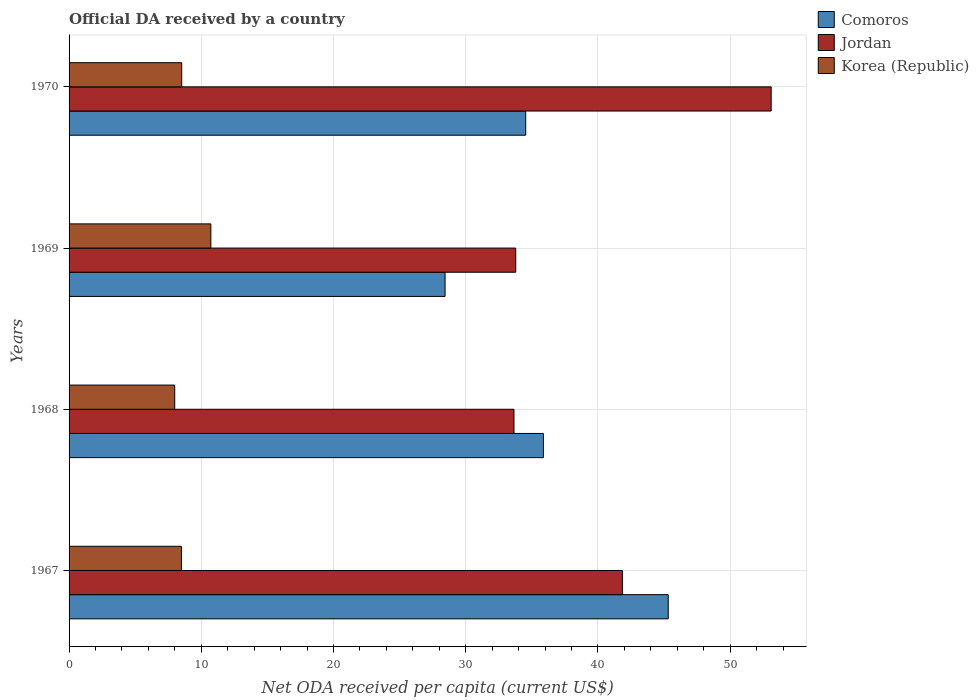How many groups of bars are there?
Keep it short and to the point. 4. How many bars are there on the 2nd tick from the top?
Make the answer very short. 3. How many bars are there on the 1st tick from the bottom?
Ensure brevity in your answer.  3. What is the label of the 4th group of bars from the top?
Your response must be concise. 1967. In how many cases, is the number of bars for a given year not equal to the number of legend labels?
Give a very brief answer. 0. What is the ODA received in in Jordan in 1968?
Give a very brief answer. 33.65. Across all years, what is the maximum ODA received in in Jordan?
Offer a terse response. 53.1. Across all years, what is the minimum ODA received in in Comoros?
Your answer should be very brief. 28.44. In which year was the ODA received in in Korea (Republic) maximum?
Your answer should be compact. 1969. In which year was the ODA received in in Korea (Republic) minimum?
Offer a terse response. 1968. What is the total ODA received in in Korea (Republic) in the graph?
Ensure brevity in your answer.  35.73. What is the difference between the ODA received in in Korea (Republic) in 1968 and that in 1970?
Your answer should be very brief. -0.53. What is the difference between the ODA received in in Korea (Republic) in 1969 and the ODA received in in Jordan in 1968?
Keep it short and to the point. -22.93. What is the average ODA received in in Jordan per year?
Your answer should be very brief. 40.6. In the year 1969, what is the difference between the ODA received in in Korea (Republic) and ODA received in in Jordan?
Make the answer very short. -23.06. What is the ratio of the ODA received in in Korea (Republic) in 1968 to that in 1969?
Ensure brevity in your answer.  0.75. What is the difference between the highest and the second highest ODA received in in Comoros?
Provide a short and direct response. 9.44. What is the difference between the highest and the lowest ODA received in in Jordan?
Your response must be concise. 19.45. Is the sum of the ODA received in in Korea (Republic) in 1967 and 1969 greater than the maximum ODA received in in Jordan across all years?
Offer a very short reply. No. What does the 1st bar from the bottom in 1967 represents?
Provide a short and direct response. Comoros. Are the values on the major ticks of X-axis written in scientific E-notation?
Keep it short and to the point. No. Does the graph contain grids?
Make the answer very short. Yes. How many legend labels are there?
Give a very brief answer. 3. How are the legend labels stacked?
Make the answer very short. Vertical. What is the title of the graph?
Provide a succinct answer. Official DA received by a country. What is the label or title of the X-axis?
Your response must be concise. Net ODA received per capita (current US$). What is the Net ODA received per capita (current US$) in Comoros in 1967?
Provide a succinct answer. 45.32. What is the Net ODA received per capita (current US$) in Jordan in 1967?
Your answer should be compact. 41.85. What is the Net ODA received per capita (current US$) in Korea (Republic) in 1967?
Offer a very short reply. 8.5. What is the Net ODA received per capita (current US$) in Comoros in 1968?
Keep it short and to the point. 35.88. What is the Net ODA received per capita (current US$) of Jordan in 1968?
Your answer should be compact. 33.65. What is the Net ODA received per capita (current US$) of Korea (Republic) in 1968?
Your response must be concise. 7.99. What is the Net ODA received per capita (current US$) of Comoros in 1969?
Keep it short and to the point. 28.44. What is the Net ODA received per capita (current US$) in Jordan in 1969?
Provide a succinct answer. 33.78. What is the Net ODA received per capita (current US$) in Korea (Republic) in 1969?
Your response must be concise. 10.72. What is the Net ODA received per capita (current US$) of Comoros in 1970?
Provide a short and direct response. 34.54. What is the Net ODA received per capita (current US$) in Jordan in 1970?
Give a very brief answer. 53.1. What is the Net ODA received per capita (current US$) in Korea (Republic) in 1970?
Give a very brief answer. 8.52. Across all years, what is the maximum Net ODA received per capita (current US$) in Comoros?
Offer a terse response. 45.32. Across all years, what is the maximum Net ODA received per capita (current US$) in Jordan?
Provide a short and direct response. 53.1. Across all years, what is the maximum Net ODA received per capita (current US$) of Korea (Republic)?
Your answer should be very brief. 10.72. Across all years, what is the minimum Net ODA received per capita (current US$) of Comoros?
Your response must be concise. 28.44. Across all years, what is the minimum Net ODA received per capita (current US$) of Jordan?
Your answer should be compact. 33.65. Across all years, what is the minimum Net ODA received per capita (current US$) in Korea (Republic)?
Give a very brief answer. 7.99. What is the total Net ODA received per capita (current US$) of Comoros in the graph?
Offer a terse response. 144.18. What is the total Net ODA received per capita (current US$) of Jordan in the graph?
Your response must be concise. 162.39. What is the total Net ODA received per capita (current US$) of Korea (Republic) in the graph?
Make the answer very short. 35.73. What is the difference between the Net ODA received per capita (current US$) in Comoros in 1967 and that in 1968?
Provide a short and direct response. 9.44. What is the difference between the Net ODA received per capita (current US$) in Jordan in 1967 and that in 1968?
Make the answer very short. 8.2. What is the difference between the Net ODA received per capita (current US$) in Korea (Republic) in 1967 and that in 1968?
Your response must be concise. 0.51. What is the difference between the Net ODA received per capita (current US$) of Comoros in 1967 and that in 1969?
Ensure brevity in your answer.  16.88. What is the difference between the Net ODA received per capita (current US$) in Jordan in 1967 and that in 1969?
Provide a succinct answer. 8.07. What is the difference between the Net ODA received per capita (current US$) of Korea (Republic) in 1967 and that in 1969?
Ensure brevity in your answer.  -2.23. What is the difference between the Net ODA received per capita (current US$) in Comoros in 1967 and that in 1970?
Your response must be concise. 10.78. What is the difference between the Net ODA received per capita (current US$) of Jordan in 1967 and that in 1970?
Offer a terse response. -11.25. What is the difference between the Net ODA received per capita (current US$) of Korea (Republic) in 1967 and that in 1970?
Make the answer very short. -0.02. What is the difference between the Net ODA received per capita (current US$) of Comoros in 1968 and that in 1969?
Make the answer very short. 7.44. What is the difference between the Net ODA received per capita (current US$) in Jordan in 1968 and that in 1969?
Offer a terse response. -0.13. What is the difference between the Net ODA received per capita (current US$) of Korea (Republic) in 1968 and that in 1969?
Keep it short and to the point. -2.73. What is the difference between the Net ODA received per capita (current US$) of Comoros in 1968 and that in 1970?
Give a very brief answer. 1.34. What is the difference between the Net ODA received per capita (current US$) of Jordan in 1968 and that in 1970?
Make the answer very short. -19.45. What is the difference between the Net ODA received per capita (current US$) in Korea (Republic) in 1968 and that in 1970?
Your answer should be very brief. -0.53. What is the difference between the Net ODA received per capita (current US$) in Comoros in 1969 and that in 1970?
Give a very brief answer. -6.1. What is the difference between the Net ODA received per capita (current US$) in Jordan in 1969 and that in 1970?
Your answer should be very brief. -19.32. What is the difference between the Net ODA received per capita (current US$) of Korea (Republic) in 1969 and that in 1970?
Ensure brevity in your answer.  2.21. What is the difference between the Net ODA received per capita (current US$) in Comoros in 1967 and the Net ODA received per capita (current US$) in Jordan in 1968?
Your response must be concise. 11.67. What is the difference between the Net ODA received per capita (current US$) in Comoros in 1967 and the Net ODA received per capita (current US$) in Korea (Republic) in 1968?
Offer a very short reply. 37.33. What is the difference between the Net ODA received per capita (current US$) in Jordan in 1967 and the Net ODA received per capita (current US$) in Korea (Republic) in 1968?
Offer a very short reply. 33.86. What is the difference between the Net ODA received per capita (current US$) in Comoros in 1967 and the Net ODA received per capita (current US$) in Jordan in 1969?
Keep it short and to the point. 11.54. What is the difference between the Net ODA received per capita (current US$) in Comoros in 1967 and the Net ODA received per capita (current US$) in Korea (Republic) in 1969?
Ensure brevity in your answer.  34.59. What is the difference between the Net ODA received per capita (current US$) in Jordan in 1967 and the Net ODA received per capita (current US$) in Korea (Republic) in 1969?
Offer a very short reply. 31.12. What is the difference between the Net ODA received per capita (current US$) in Comoros in 1967 and the Net ODA received per capita (current US$) in Jordan in 1970?
Your response must be concise. -7.78. What is the difference between the Net ODA received per capita (current US$) in Comoros in 1967 and the Net ODA received per capita (current US$) in Korea (Republic) in 1970?
Offer a very short reply. 36.8. What is the difference between the Net ODA received per capita (current US$) of Jordan in 1967 and the Net ODA received per capita (current US$) of Korea (Republic) in 1970?
Offer a very short reply. 33.33. What is the difference between the Net ODA received per capita (current US$) of Comoros in 1968 and the Net ODA received per capita (current US$) of Jordan in 1969?
Your answer should be very brief. 2.1. What is the difference between the Net ODA received per capita (current US$) of Comoros in 1968 and the Net ODA received per capita (current US$) of Korea (Republic) in 1969?
Provide a succinct answer. 25.15. What is the difference between the Net ODA received per capita (current US$) in Jordan in 1968 and the Net ODA received per capita (current US$) in Korea (Republic) in 1969?
Offer a very short reply. 22.93. What is the difference between the Net ODA received per capita (current US$) in Comoros in 1968 and the Net ODA received per capita (current US$) in Jordan in 1970?
Your answer should be very brief. -17.23. What is the difference between the Net ODA received per capita (current US$) in Comoros in 1968 and the Net ODA received per capita (current US$) in Korea (Republic) in 1970?
Your answer should be very brief. 27.36. What is the difference between the Net ODA received per capita (current US$) of Jordan in 1968 and the Net ODA received per capita (current US$) of Korea (Republic) in 1970?
Ensure brevity in your answer.  25.13. What is the difference between the Net ODA received per capita (current US$) of Comoros in 1969 and the Net ODA received per capita (current US$) of Jordan in 1970?
Your response must be concise. -24.66. What is the difference between the Net ODA received per capita (current US$) in Comoros in 1969 and the Net ODA received per capita (current US$) in Korea (Republic) in 1970?
Provide a succinct answer. 19.92. What is the difference between the Net ODA received per capita (current US$) of Jordan in 1969 and the Net ODA received per capita (current US$) of Korea (Republic) in 1970?
Your answer should be compact. 25.26. What is the average Net ODA received per capita (current US$) of Comoros per year?
Give a very brief answer. 36.04. What is the average Net ODA received per capita (current US$) in Jordan per year?
Offer a terse response. 40.6. What is the average Net ODA received per capita (current US$) of Korea (Republic) per year?
Provide a succinct answer. 8.93. In the year 1967, what is the difference between the Net ODA received per capita (current US$) of Comoros and Net ODA received per capita (current US$) of Jordan?
Provide a short and direct response. 3.47. In the year 1967, what is the difference between the Net ODA received per capita (current US$) in Comoros and Net ODA received per capita (current US$) in Korea (Republic)?
Provide a short and direct response. 36.82. In the year 1967, what is the difference between the Net ODA received per capita (current US$) of Jordan and Net ODA received per capita (current US$) of Korea (Republic)?
Give a very brief answer. 33.35. In the year 1968, what is the difference between the Net ODA received per capita (current US$) in Comoros and Net ODA received per capita (current US$) in Jordan?
Give a very brief answer. 2.23. In the year 1968, what is the difference between the Net ODA received per capita (current US$) in Comoros and Net ODA received per capita (current US$) in Korea (Republic)?
Your response must be concise. 27.89. In the year 1968, what is the difference between the Net ODA received per capita (current US$) in Jordan and Net ODA received per capita (current US$) in Korea (Republic)?
Your response must be concise. 25.66. In the year 1969, what is the difference between the Net ODA received per capita (current US$) in Comoros and Net ODA received per capita (current US$) in Jordan?
Your response must be concise. -5.34. In the year 1969, what is the difference between the Net ODA received per capita (current US$) of Comoros and Net ODA received per capita (current US$) of Korea (Republic)?
Give a very brief answer. 17.72. In the year 1969, what is the difference between the Net ODA received per capita (current US$) in Jordan and Net ODA received per capita (current US$) in Korea (Republic)?
Ensure brevity in your answer.  23.06. In the year 1970, what is the difference between the Net ODA received per capita (current US$) in Comoros and Net ODA received per capita (current US$) in Jordan?
Ensure brevity in your answer.  -18.57. In the year 1970, what is the difference between the Net ODA received per capita (current US$) of Comoros and Net ODA received per capita (current US$) of Korea (Republic)?
Your answer should be compact. 26.02. In the year 1970, what is the difference between the Net ODA received per capita (current US$) in Jordan and Net ODA received per capita (current US$) in Korea (Republic)?
Offer a terse response. 44.58. What is the ratio of the Net ODA received per capita (current US$) in Comoros in 1967 to that in 1968?
Your response must be concise. 1.26. What is the ratio of the Net ODA received per capita (current US$) in Jordan in 1967 to that in 1968?
Your response must be concise. 1.24. What is the ratio of the Net ODA received per capita (current US$) of Korea (Republic) in 1967 to that in 1968?
Your answer should be very brief. 1.06. What is the ratio of the Net ODA received per capita (current US$) in Comoros in 1967 to that in 1969?
Provide a succinct answer. 1.59. What is the ratio of the Net ODA received per capita (current US$) in Jordan in 1967 to that in 1969?
Ensure brevity in your answer.  1.24. What is the ratio of the Net ODA received per capita (current US$) in Korea (Republic) in 1967 to that in 1969?
Your answer should be compact. 0.79. What is the ratio of the Net ODA received per capita (current US$) of Comoros in 1967 to that in 1970?
Offer a terse response. 1.31. What is the ratio of the Net ODA received per capita (current US$) of Jordan in 1967 to that in 1970?
Keep it short and to the point. 0.79. What is the ratio of the Net ODA received per capita (current US$) in Comoros in 1968 to that in 1969?
Make the answer very short. 1.26. What is the ratio of the Net ODA received per capita (current US$) in Jordan in 1968 to that in 1969?
Provide a short and direct response. 1. What is the ratio of the Net ODA received per capita (current US$) in Korea (Republic) in 1968 to that in 1969?
Provide a succinct answer. 0.75. What is the ratio of the Net ODA received per capita (current US$) of Comoros in 1968 to that in 1970?
Offer a terse response. 1.04. What is the ratio of the Net ODA received per capita (current US$) of Jordan in 1968 to that in 1970?
Your response must be concise. 0.63. What is the ratio of the Net ODA received per capita (current US$) in Korea (Republic) in 1968 to that in 1970?
Ensure brevity in your answer.  0.94. What is the ratio of the Net ODA received per capita (current US$) of Comoros in 1969 to that in 1970?
Your answer should be very brief. 0.82. What is the ratio of the Net ODA received per capita (current US$) in Jordan in 1969 to that in 1970?
Your answer should be very brief. 0.64. What is the ratio of the Net ODA received per capita (current US$) of Korea (Republic) in 1969 to that in 1970?
Ensure brevity in your answer.  1.26. What is the difference between the highest and the second highest Net ODA received per capita (current US$) in Comoros?
Your response must be concise. 9.44. What is the difference between the highest and the second highest Net ODA received per capita (current US$) of Jordan?
Your response must be concise. 11.25. What is the difference between the highest and the second highest Net ODA received per capita (current US$) in Korea (Republic)?
Provide a succinct answer. 2.21. What is the difference between the highest and the lowest Net ODA received per capita (current US$) of Comoros?
Your answer should be very brief. 16.88. What is the difference between the highest and the lowest Net ODA received per capita (current US$) in Jordan?
Keep it short and to the point. 19.45. What is the difference between the highest and the lowest Net ODA received per capita (current US$) of Korea (Republic)?
Your answer should be very brief. 2.73. 